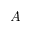<formula> <loc_0><loc_0><loc_500><loc_500>A</formula> 